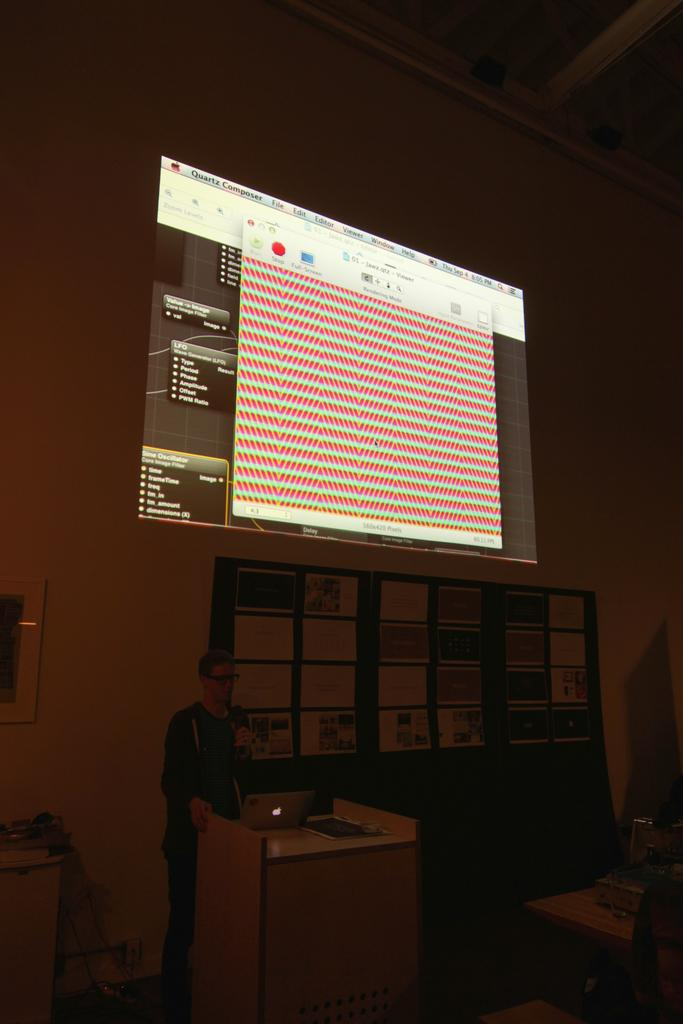What is the person in the image holding? The person is holding a mic in the image. Where is the person standing in relation to the podium? The person is standing in front of a podium. What electronic device is on the table in the image? There is a laptop on the table in the image. What type of reading material is on the table? There is a book on the table in the image. What can be seen at the back side of the image? There is a screen visible at the back side of the image. Can you see the person's father giving them a kiss in the image? There is no person's father or any kissing action present in the image. 